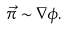Convert formula to latex. <formula><loc_0><loc_0><loc_500><loc_500>\vec { \pi } \sim \nabla \phi .</formula> 